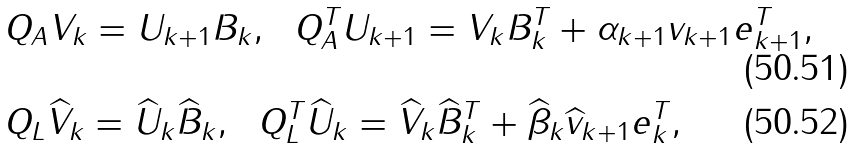<formula> <loc_0><loc_0><loc_500><loc_500>& Q _ { A } V _ { k } = U _ { k + 1 } B _ { k } , \ \ Q _ { A } ^ { T } U _ { k + 1 } = V _ { k } B _ { k } ^ { T } + \alpha _ { k + 1 } v _ { k + 1 } e _ { k + 1 } ^ { T } , \\ & Q _ { L } \widehat { V } _ { k } = \widehat { U } _ { k } \widehat { B } _ { k } , \ \ Q _ { L } ^ { T } \widehat { U } _ { k } = \widehat { V } _ { k } \widehat { B } _ { k } ^ { T } + \widehat { \beta } _ { k } \widehat { v } _ { k + 1 } e _ { k } ^ { T } ,</formula> 